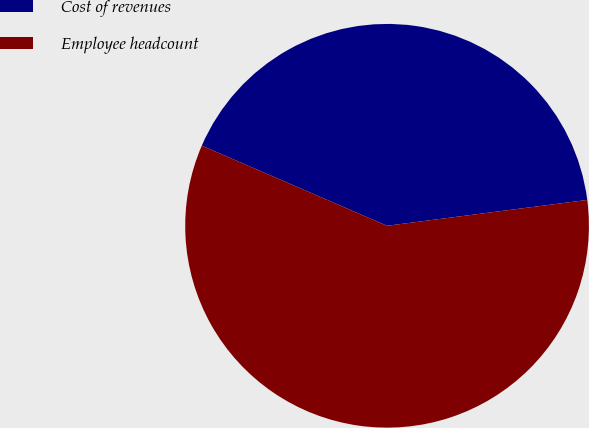Convert chart to OTSL. <chart><loc_0><loc_0><loc_500><loc_500><pie_chart><fcel>Cost of revenues<fcel>Employee headcount<nl><fcel>41.46%<fcel>58.54%<nl></chart> 